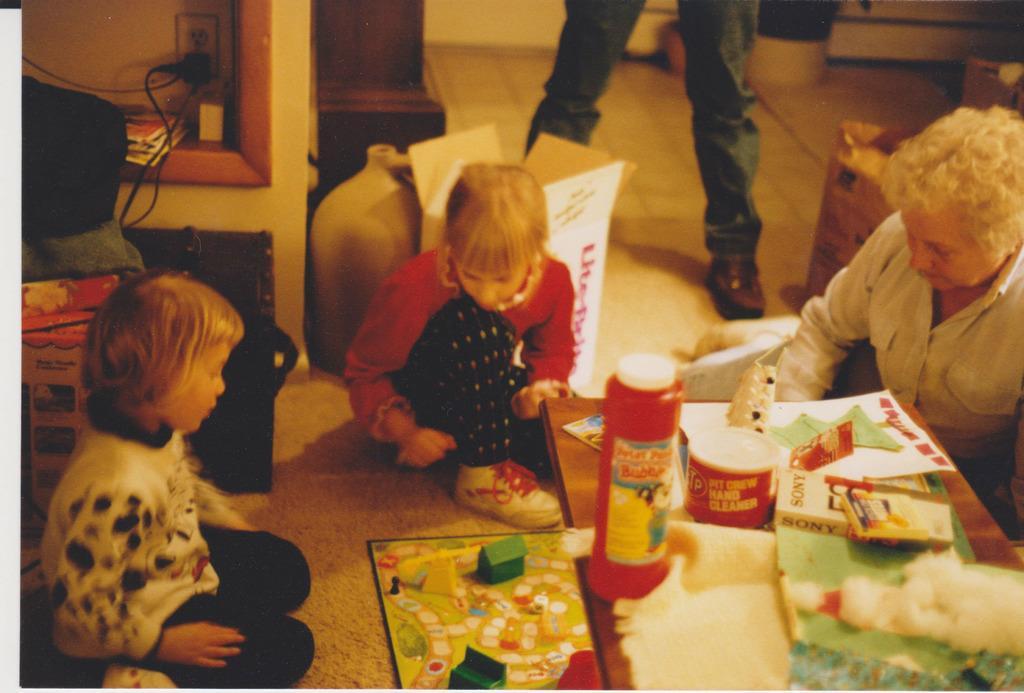Please provide a concise description of this image. The image is inside the room. In the image there are three people sitting in front of a table, on table we can see bottle,book,paper. In background there is a person standing and we can also see a switch board at bottom there is a toy and a mat. 